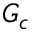Convert formula to latex. <formula><loc_0><loc_0><loc_500><loc_500>G _ { c }</formula> 